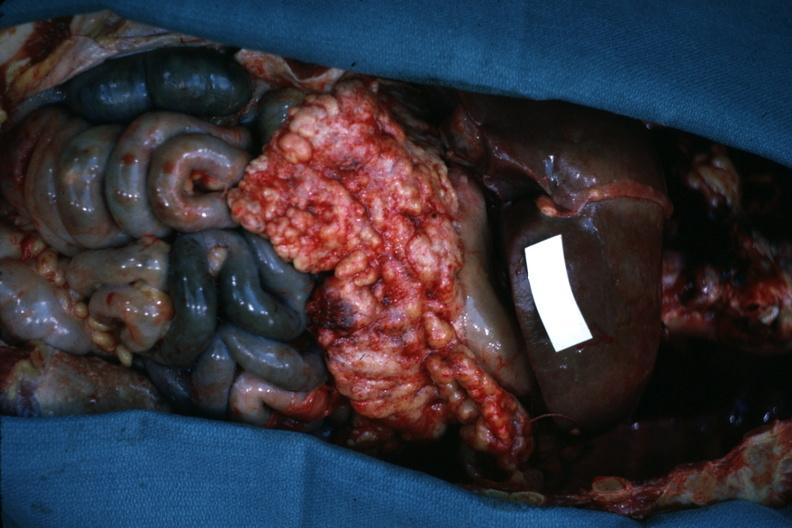s opened abdominal cavity with massive tumor in omentum none apparent in liver nor over peritoneal surfaces gut ischemic?
Answer the question using a single word or phrase. Yes 